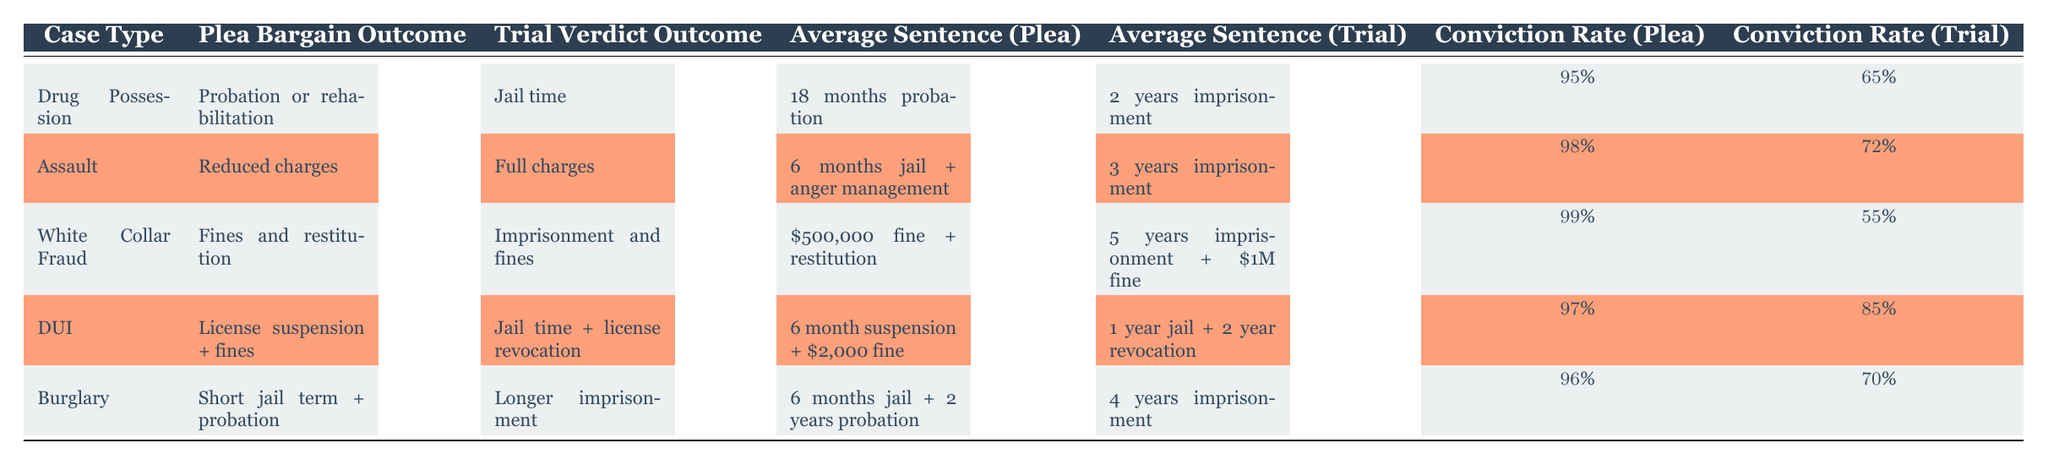What is the average sentence for drug possession cases when a plea bargain is accepted? According to the table, for drug possession cases resulting in a plea bargain, the average sentence is 18 months probation.
Answer: 18 months probation What is the conviction rate for DUI cases resulting in a plea bargain? The table indicates that the conviction rate for DUI cases when a plea bargain is accepted is 97%.
Answer: 97% Which case type has the highest average sentence in trial verdicts? The average sentence for white collar fraud cases in trial verdicts is 5 years imprisonment plus a 1 million dollar fine, which is more severe compared to average trial sentences for other case types listed.
Answer: White Collar Fraud Is the conviction rate for plea bargains generally higher than for trial verdicts in the table? By comparing the conviction rates, plea bargains have higher rates: Drug Possession (95% vs 65%), Assault (98% vs 72%), White Collar Fraud (99% vs 55%), DUI (97% vs 85%), and Burglary (96% vs 70%). To confirm, all plea bargain rates exceed trial verdict rates.
Answer: Yes Calculate the difference in average sentences between plea bargains and trial verdicts for assault cases. The average sentence for plea bargains in assault cases is 6 months jail plus anger management, whereas the trial verdict equates to 3 years imprisonment, which is significantly longer. In months, that's approximately (6 + 0) months for plea vs (36) months in trial, resulting in a difference of 30 months favoring the trial.
Answer: 30 months For which case type is the trial conviction rate lower than the plea conviction rate by the greatest margin? Looking at the rates: Drug Possession (30%), Assault (26%), White Collar Fraud (44%), DUI (12%), and Burglary (26%), the white collar fraud case shows the greatest difference with a 44% lower conviction rate in trials compared to pleas.
Answer: White Collar Fraud What is the average sentence for burglary cases under a plea bargain? The table shows that for burglary cases with a plea bargain, the average sentence is 6 months jail and 2 years probation.
Answer: 6 months jail + 2 years probation Does every case type show a reduction from full charges to reduced charges in plea bargains? A review of the table reveals that all documented case types detail a reduction of some form, either in terms of sentence length or severity of punishment, asserting that the statement holds true.
Answer: Yes 